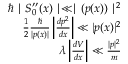<formula> <loc_0><loc_0><loc_500><loc_500>{ \begin{array} { r } { \hbar { | } S _ { 0 } ^ { \prime \prime } ( x ) | \ll | ( p ( x ) ) | ^ { 2 } } \\ { { \frac { 1 } { 2 } } { \frac { } { | p ( x ) | } } \left | { \frac { d p ^ { 2 } } { d x } } \right | \ll | p ( x ) | ^ { 2 } } \\ { \lambda \left | { \frac { d V } { d x } } \right | \ll { \frac { | p | ^ { 2 } } { m } } } \end{array} }</formula> 